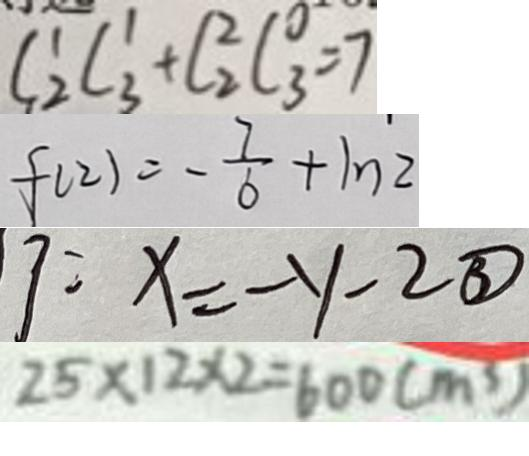<formula> <loc_0><loc_0><loc_500><loc_500>C ^ { 1 } _ { 2 } C _ { 3 } ^ { 1 } + C _ { 2 } ^ { 2 } C _ { 3 } ^ { 0 } = 7 
 f ( 2 ) = - \frac { 7 } { 6 } + 1 n 2 
 x = - y - 2 \textcircled { 3 } 
 2 5 \times 1 2 \times 2 = 6 0 0 ( m ^ { 3 } )</formula> 